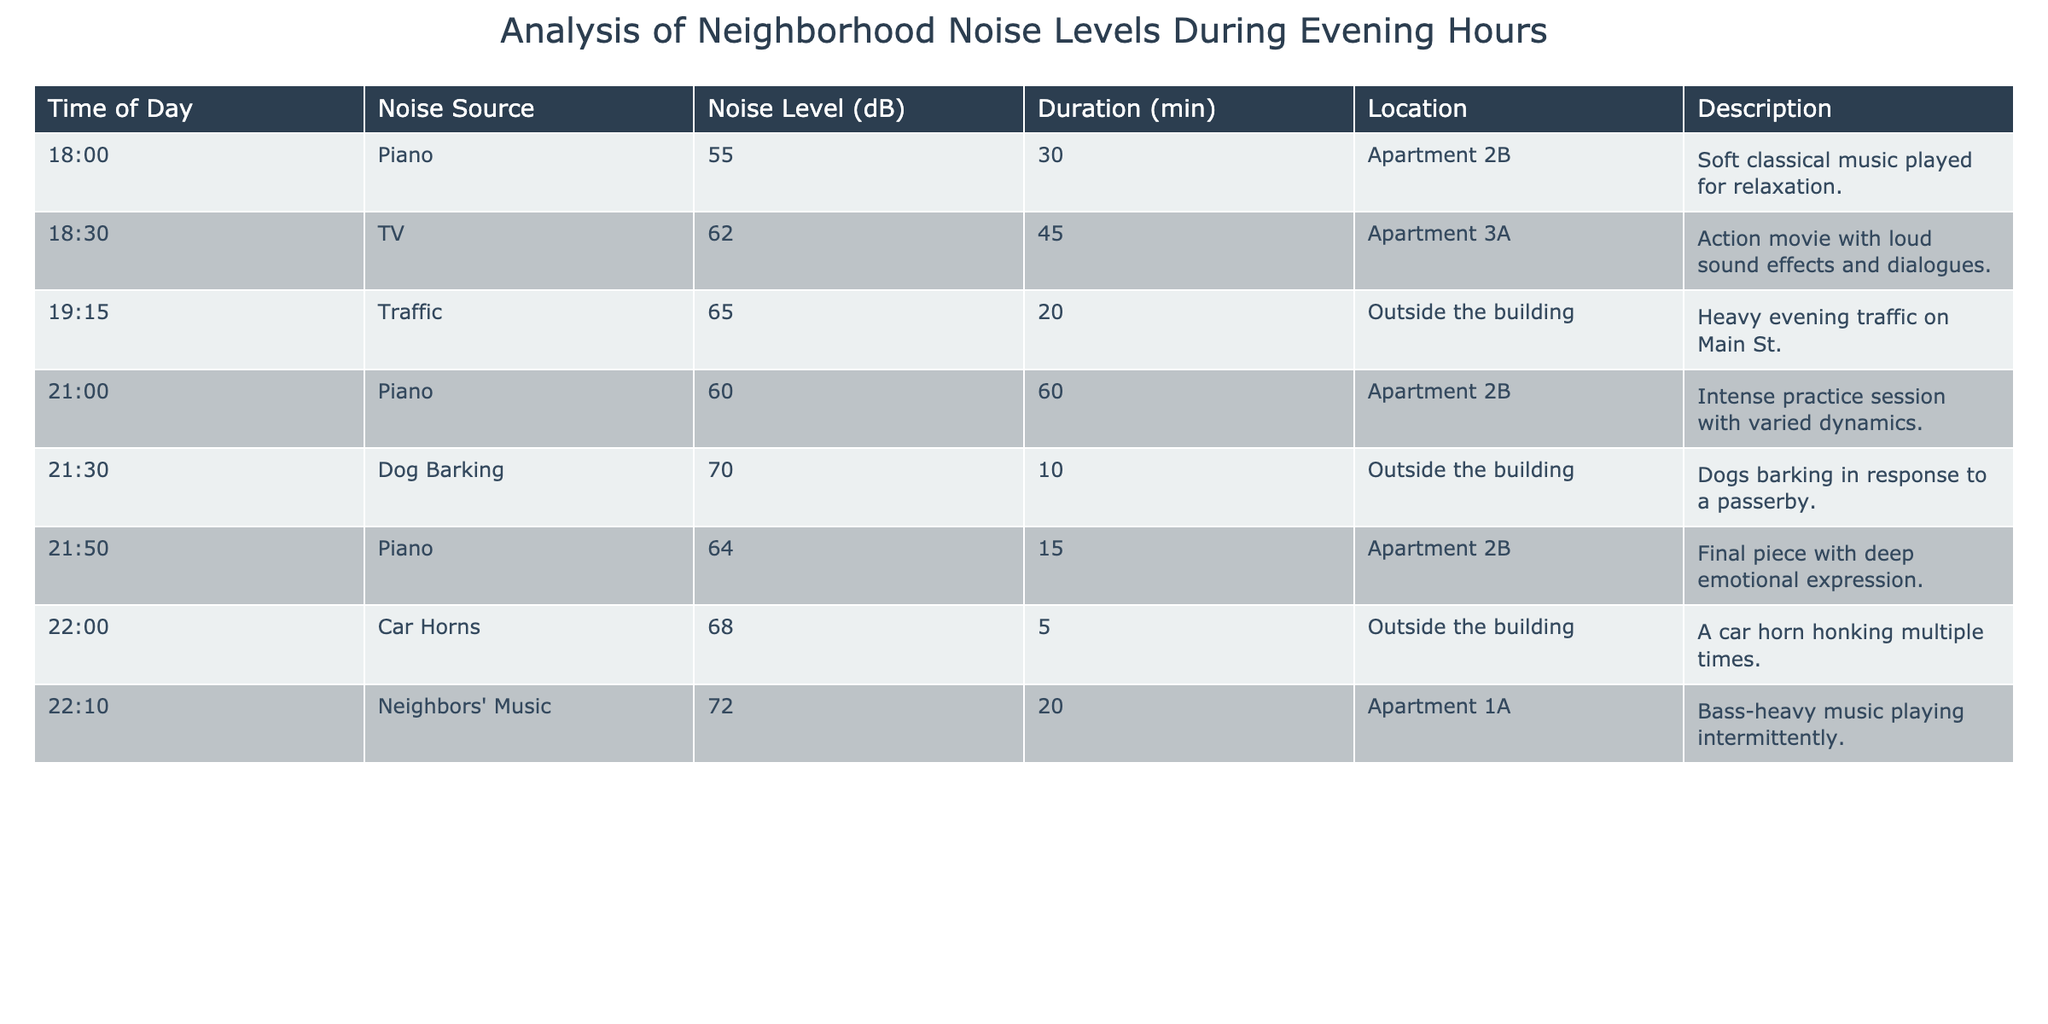What was the highest noise level recorded? The highest noise level in the table is 72 dB, recorded from the neighbors' music at 22:10.
Answer: 72 dB How many minutes did the piano play in total? The piano played for 30 minutes at 18:00, 60 minutes at 21:00, and 15 minutes at 21:50. Adding these durations gives 30 + 60 + 15 = 105 minutes.
Answer: 105 minutes Did any noise source exceed 70 dB? The noise sources that exceeded 70 dB include dog barking (70 dB), neighbors' music (72 dB), which confirms that there are recordings above 70 dB.
Answer: Yes What was the average noise level of piano performances? The noise levels for the piano performances are 55 dB, 60 dB, and 64 dB. Adding these gives 55 + 60 + 64 = 179 dB and dividing by 3 gives an average of 179 / 3 = 59.67 dB, which rounds to 60 dB.
Answer: 60 dB How does the noise level from the television compare with that from traffic? The noise level from the TV is 62 dB while traffic noise is 65 dB. So, traffic (65 dB) is louder than TV (62 dB) by 3 dB.
Answer: Traffic is louder by 3 dB 